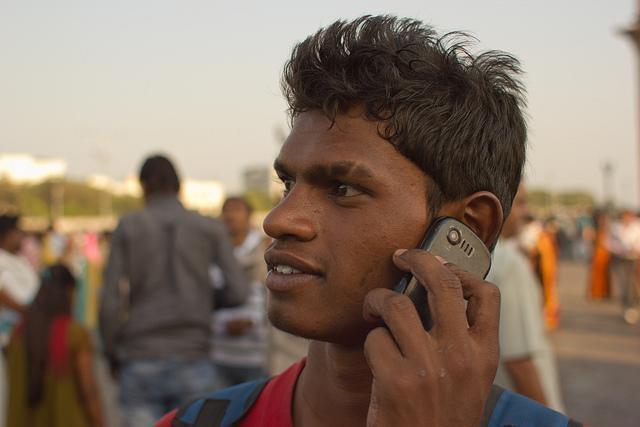What is a famous company that makes the device the man is holding?
From the following set of four choices, select the accurate answer to respond to the question.
Options: Samsung, dell, hitachi, hoover. Samsung. 